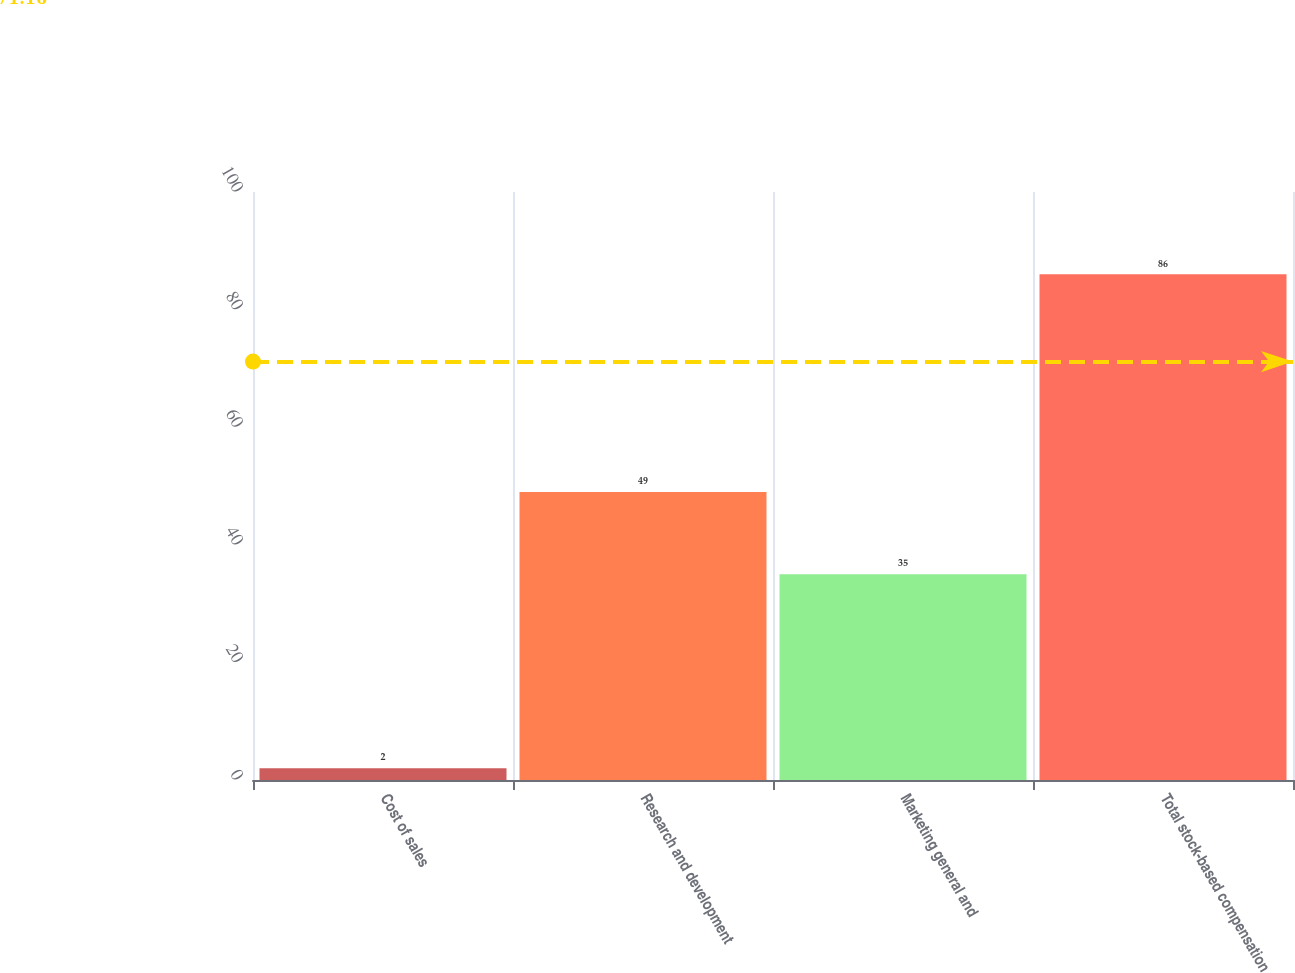<chart> <loc_0><loc_0><loc_500><loc_500><bar_chart><fcel>Cost of sales<fcel>Research and development<fcel>Marketing general and<fcel>Total stock-based compensation<nl><fcel>2<fcel>49<fcel>35<fcel>86<nl></chart> 